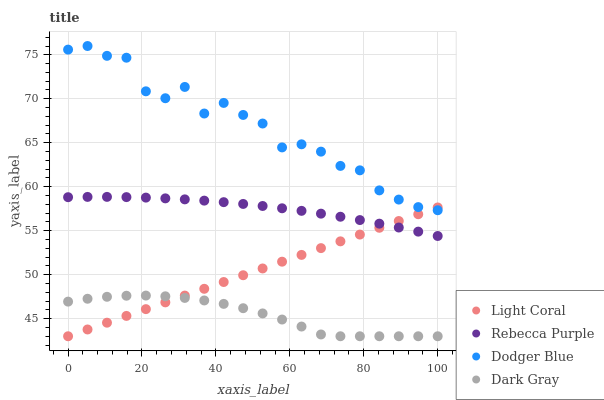Does Dark Gray have the minimum area under the curve?
Answer yes or no. Yes. Does Dodger Blue have the maximum area under the curve?
Answer yes or no. Yes. Does Dodger Blue have the minimum area under the curve?
Answer yes or no. No. Does Dark Gray have the maximum area under the curve?
Answer yes or no. No. Is Light Coral the smoothest?
Answer yes or no. Yes. Is Dodger Blue the roughest?
Answer yes or no. Yes. Is Dark Gray the smoothest?
Answer yes or no. No. Is Dark Gray the roughest?
Answer yes or no. No. Does Light Coral have the lowest value?
Answer yes or no. Yes. Does Dodger Blue have the lowest value?
Answer yes or no. No. Does Dodger Blue have the highest value?
Answer yes or no. Yes. Does Dark Gray have the highest value?
Answer yes or no. No. Is Rebecca Purple less than Dodger Blue?
Answer yes or no. Yes. Is Dodger Blue greater than Dark Gray?
Answer yes or no. Yes. Does Rebecca Purple intersect Light Coral?
Answer yes or no. Yes. Is Rebecca Purple less than Light Coral?
Answer yes or no. No. Is Rebecca Purple greater than Light Coral?
Answer yes or no. No. Does Rebecca Purple intersect Dodger Blue?
Answer yes or no. No. 